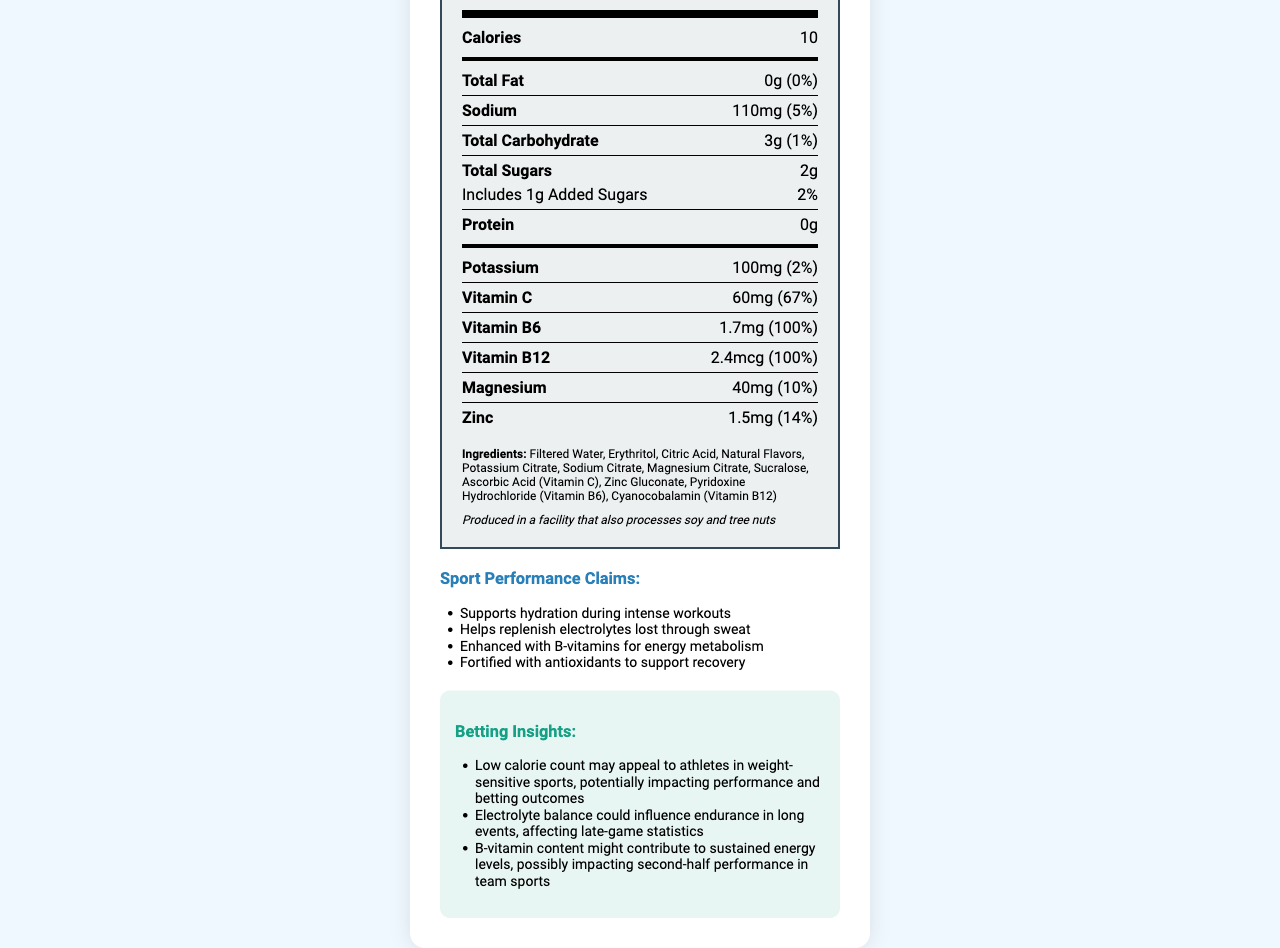What is the serving size of HydroBoost Elite? The serving size is listed in the nutrition facts section under the heading "Serving size".
Answer: 16 fl oz (480 mL) How many calories are in a serving of HydroBoost Elite? The calorie count is listed in the nutrient information section under "Calories".
Answer: 10 What is the amount of sodium per serving in HydroBoost Elite? The amount of sodium per serving is found in the nutrient information section under "Sodium".
Answer: 110mg What percentage of the daily value for Vitamin C does HydroBoost Elite provide? The daily value percentage for Vitamin C is listed in the nutrient information section under "Vitamin C".
Answer: 67% Are there any added sugars in HydroBoost Elite? There is a section under "Total Sugars" that mentions "Includes 1g Added Sugars".
Answer: Yes Does HydroBoost Elite contain any protein? The protein content is listed as 0g in the document.
Answer: No What minerals are present in HydroBoost Elite? A. Calcium and Magnesium B. Magnesium and Zinc C. Iron and Potassium D. Calcium and Iron The minerals Magnesium (40mg) and Zinc (1.5mg) are listed in the nutritional information section under their respective names.
Answer: B. Magnesium and Zinc Which of the following is a sport performance claim made by HydroBoost Elite? A. Increases muscle mass B. Supports hydration during intense workouts C. Enhances mental alertness D. Reduces joint pain The performance claims listed in the document include "Supports hydration during intense workouts".
Answer: B. Supports hydration during intense workouts Is HydroBoost Elite produced in a facility that processes any allergens? The document mentions that it is produced in a facility that also processes soy and tree nuts under allergen information.
Answer: Yes Does HydroBoost Elite include any type of Vitamin B? The document lists both Vitamin B6 and Vitamin B12 in the nutrient information section.
Answer: Yes Summarize the key nutritional aspects of HydroBoost Elite. The summary covers the main product information from calories and macronutrients to essential vitamins and minerals, along with performance-boosting claims made by the beverage.
Answer: HydroBoost Elite is a low-calorie sports hydration beverage with 10 calories per serving. It contains 0g of total fat and protein, 110mg of sodium, 3g of total carbohydrates (including 2g of sugars and 1g of added sugars). Key nutrients include 100mg of potassium, 60mg of Vitamin C, 1.7mg of Vitamin B6, 2.4mcg of Vitamin B12, 40mg of magnesium, and 1.5mg of zinc. It supports hydration and replenishes electrolytes, with added benefits from B-vitamins and antioxidants. Which electrolyte does HydroBoost Elite contain more of, Potassium or Sodium? HydroBoost Elite contains 110mg of sodium compared to 100mg of potassium as listed in the nutrient information section.
Answer: Sodium Does HydroBoost Elite provide any benefits for recovery? One of the performance claims listed is "Fortified with antioxidants to support recovery".
Answer: Yes What is the purpose of the betting insights section in the document? The betting insights section is meant to provide information on how aspects like low calorie count, electrolyte balance, and B-vitamin content might influence athletic performance in ways relevant to sports betting.
Answer: To highlight how the nutritional content of HydroBoost Elite could affect athletic performance and, consequently, sports betting outcomes. What is the main sweetener used in HydroBoost Elite? Erythritol is listed as one of the ingredients in the beverage.
Answer: Erythritol What impact might the B-vitamin content of HydroBoost Elite have on athletes, according to the betting insights? The betting insights note that the B-vitamin content could help sustain energy levels, which might influence performance in the later stages of competitions.
Answer: It might contribute to sustained energy levels, possibly impacting second-half performance in team sports. What company's logo is displayed on the document? The document provided does not include any information about a company's logo, so this cannot be determined.
Answer: Cannot be determined How much-added sugar is in HydroBoost Elite? The document specifies that there are 1g of added sugars in the "Total Sugars" section.
Answer: 1g 